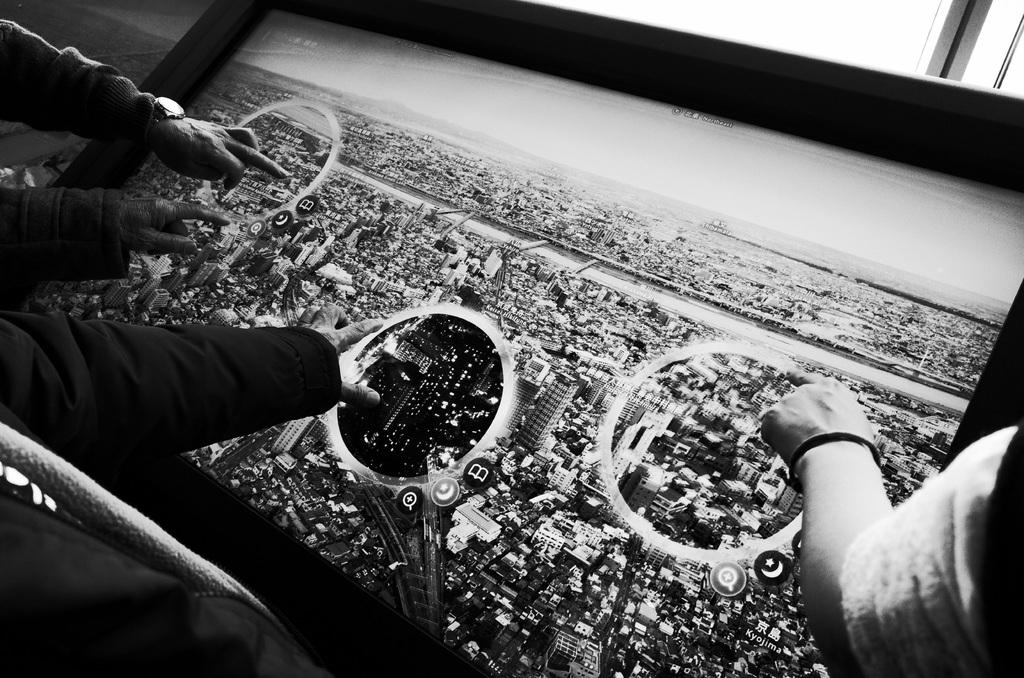What is happening in the image involving hands and a screen? There are hands touching a screen in the image. What can be seen on the screen that the hands are touching? The screen displays buildings. Are there any accessories visible on the hands in the image? Yes, there is a watch on one of the hands. How does the fireman feel about the comfort of the ring in the image? There is no fireman or ring present in the image. 